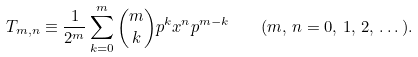Convert formula to latex. <formula><loc_0><loc_0><loc_500><loc_500>T _ { m , n } \equiv \frac { 1 } { 2 ^ { m } } \sum _ { k = 0 } ^ { m } \binom { m } { k } p ^ { k } x ^ { n } p ^ { m - k } \quad ( m , \, n = 0 , \, 1 , \, 2 , \, \dots ) .</formula> 